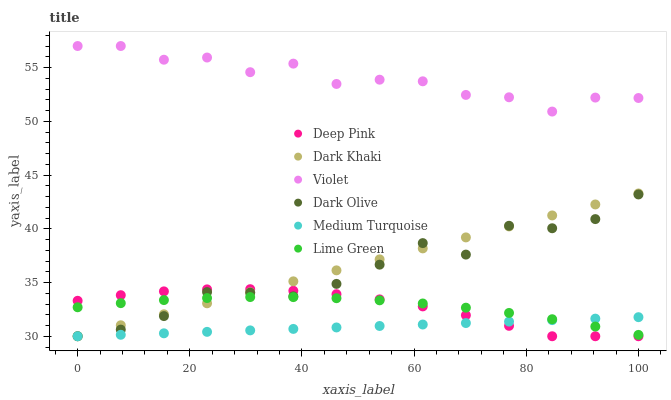Does Medium Turquoise have the minimum area under the curve?
Answer yes or no. Yes. Does Violet have the maximum area under the curve?
Answer yes or no. Yes. Does Dark Olive have the minimum area under the curve?
Answer yes or no. No. Does Dark Olive have the maximum area under the curve?
Answer yes or no. No. Is Medium Turquoise the smoothest?
Answer yes or no. Yes. Is Violet the roughest?
Answer yes or no. Yes. Is Dark Olive the smoothest?
Answer yes or no. No. Is Dark Olive the roughest?
Answer yes or no. No. Does Deep Pink have the lowest value?
Answer yes or no. Yes. Does Violet have the lowest value?
Answer yes or no. No. Does Violet have the highest value?
Answer yes or no. Yes. Does Dark Olive have the highest value?
Answer yes or no. No. Is Dark Khaki less than Violet?
Answer yes or no. Yes. Is Violet greater than Lime Green?
Answer yes or no. Yes. Does Deep Pink intersect Dark Khaki?
Answer yes or no. Yes. Is Deep Pink less than Dark Khaki?
Answer yes or no. No. Is Deep Pink greater than Dark Khaki?
Answer yes or no. No. Does Dark Khaki intersect Violet?
Answer yes or no. No. 